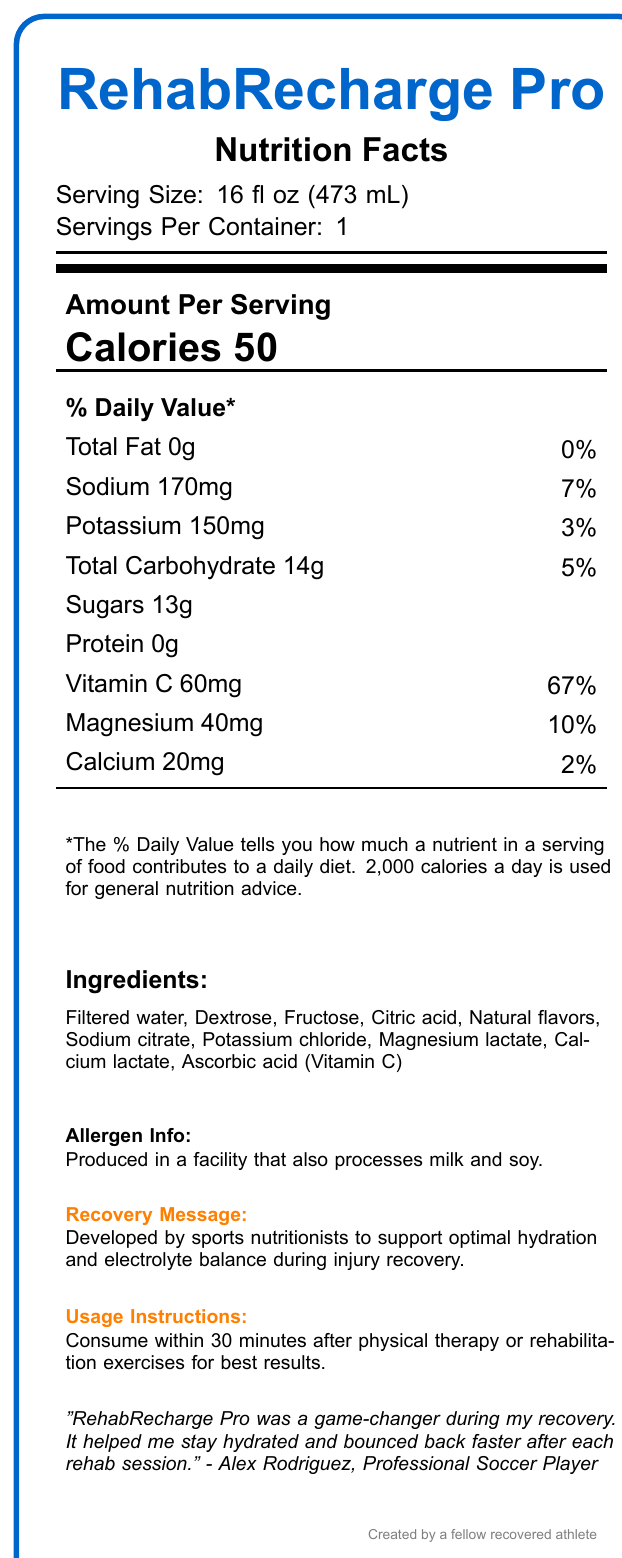who is the professional soccer player endorsing RehabRecharge Pro? The athlete testimonial states, "RehabRecharge Pro was a game-changer during my recovery. It helped me stay hydrated and bounced back faster after each rehab session. - Alex Rodriguez, Professional Soccer Player".
Answer: Alex Rodriguez what is the serving size of RehabRecharge Pro? The document specifies the serving size as 16 fl oz (473 mL).
Answer: 16 fl oz (473 mL) how many calories are in one serving of RehabRecharge Pro? The document states that there are 50 calories per serving.
Answer: 50 calories what percentage of the daily value of Vitamin C does one serving provide? Under the "Vitamin C" section, it is mentioned that one serving provides 60mg, which is 67% of the daily value.
Answer: 67% which ingredient is listed first in the ingredients section? The ingredients section lists "Filtered water" as the first ingredient.
Answer: Filtered water what is the total amount of sugars found in one serving of RehabRecharge Pro? The document specifies that there are 13g of sugars per serving.
Answer: 13g are there any proteins in RehabRecharge Pro? The document lists "Protein 0g," indicating there are no proteins in it.
Answer: No which two minerals are listed with the respective daily values provided? A. Sodium and Potassium B. Potassium and Magnesium C. Calcium and Magnesium D. Sodium and Magnesium Sodium has 7% and Magnesium has 10% daily values mentioned, while others do not provide respective daily values for this context.
Answer: D how often should you consume RehabRecharge Pro for optimal results? A. Every morning B. Within 30 minutes after physical therapy or rehabilitation exercises C. Before bed D. Before workouts The usage instructions specify that the best results are obtained when consumed within 30 minutes after physical therapy or rehabilitation exercises.
Answer: B does RehabRecharge Pro contain any allergens? The allergen information indicates it is produced in a facility that also processes milk and soy.
Answer: Yes what is the main idea of the RehabRecharge Pro document? The document primarily focuses on RehabRecharge Pro as an electrolyte-rich sports drink developed by sports nutritionists to support optimal hydration and electrolyte balance during injury recovery, with supporting details such as nutritional content, ingredients, allergen info, and athlete endorsements.
Answer: Developed for optimal hydration during injury recovery what specific injury did Alex Rodriguez recover from? The document does not provide information about the specific injury Alex Rodriguez recovered from.
Answer: Cannot be determined 